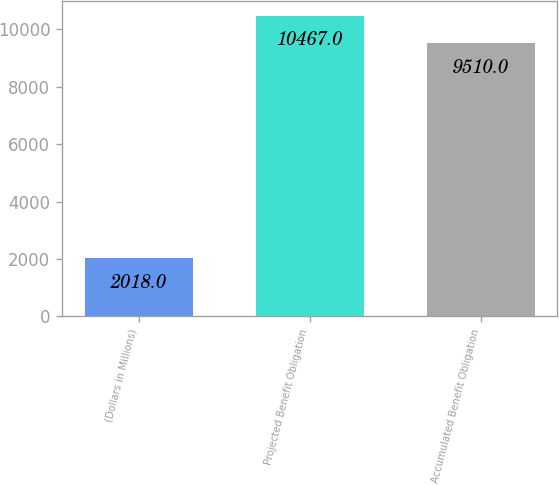<chart> <loc_0><loc_0><loc_500><loc_500><bar_chart><fcel>(Dollars in Millions)<fcel>Projected Benefit Obligation<fcel>Accumulated Benefit Obligation<nl><fcel>2018<fcel>10467<fcel>9510<nl></chart> 